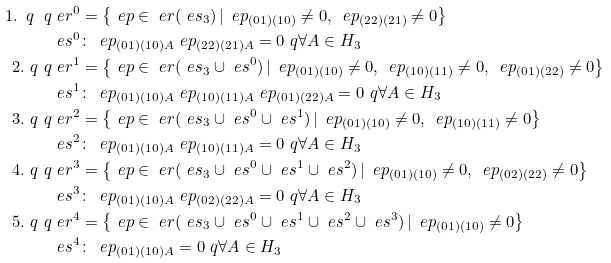Convert formula to latex. <formula><loc_0><loc_0><loc_500><loc_500>1 . \ q \ q & \ e r ^ { 0 } = \left \{ \ e p \in \ e r ( \ e s _ { 3 } ) \, | \, \ e p _ { ( 0 1 ) ( 1 0 ) } \neq 0 , \, \ e p _ { ( 2 2 ) ( 2 1 ) } \neq 0 \right \} \\ & \ e s ^ { 0 } \colon \, \ e p _ { ( 0 1 ) ( 1 0 ) A } \ e p _ { ( 2 2 ) ( 2 1 ) A } = 0 \ q \forall A \in H _ { 3 } \\ 2 . \ q \ q & \ e r ^ { 1 } = \left \{ \ e p \in \ e r ( \ e s _ { 3 } \cup \ e s ^ { 0 } ) \, | \, \ e p _ { ( 0 1 ) ( 1 0 ) } \neq 0 , \, \ e p _ { ( 1 0 ) ( 1 1 ) } \neq 0 , \, \ e p _ { ( 0 1 ) ( 2 2 ) } \neq 0 \right \} \\ & \ e s ^ { 1 } \colon \, \ e p _ { ( 0 1 ) ( 1 0 ) A } \ e p _ { ( 1 0 ) ( 1 1 ) A } \ e p _ { ( 0 1 ) ( 2 2 ) A } = 0 \ q \forall A \in H _ { 3 } \\ 3 . \ q \ q & \ e r ^ { 2 } = \left \{ \ e p \in \ e r ( \ e s _ { 3 } \cup \ e s ^ { 0 } \cup \ e s ^ { 1 } ) \, | \, \ e p _ { ( 0 1 ) ( 1 0 ) } \neq 0 , \, \ e p _ { ( 1 0 ) ( 1 1 ) } \neq 0 \right \} \\ & \ e s ^ { 2 } \colon \, \ e p _ { ( 0 1 ) ( 1 0 ) A } \ e p _ { ( 1 0 ) ( 1 1 ) A } = 0 \ q \forall A \in H _ { 3 } \\ 4 . \ q \ q & \ e r ^ { 3 } = \left \{ \ e p \in \ e r ( \ e s _ { 3 } \cup \ e s ^ { 0 } \cup \ e s ^ { 1 } \cup \ e s ^ { 2 } ) \, | \, \ e p _ { ( 0 1 ) ( 1 0 ) } \neq 0 , \, \ e p _ { ( 0 2 ) ( 2 2 ) } \neq 0 \right \} \\ & \ e s ^ { 3 } \colon \, \ e p _ { ( 0 1 ) ( 1 0 ) A } \ e p _ { ( 0 2 ) ( 2 2 ) A } = 0 \ q \forall A \in H _ { 3 } \\ 5 . \ q \ q & \ e r ^ { 4 } = \left \{ \ e p \in \ e r ( \ e s _ { 3 } \cup \ e s ^ { 0 } \cup \ e s ^ { 1 } \cup \ e s ^ { 2 } \cup \ e s ^ { 3 } ) \, | \, \ e p _ { ( 0 1 ) ( 1 0 ) } \neq 0 \right \} \\ & \ e s ^ { 4 } \colon \, \ e p _ { ( 0 1 ) ( 1 0 ) A } = 0 \ q \forall A \in H _ { 3 }</formula> 